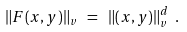Convert formula to latex. <formula><loc_0><loc_0><loc_500><loc_500>\| F ( x , y ) \| _ { v } \ = \ \| ( x , y ) \| _ { v } ^ { d } \ .</formula> 